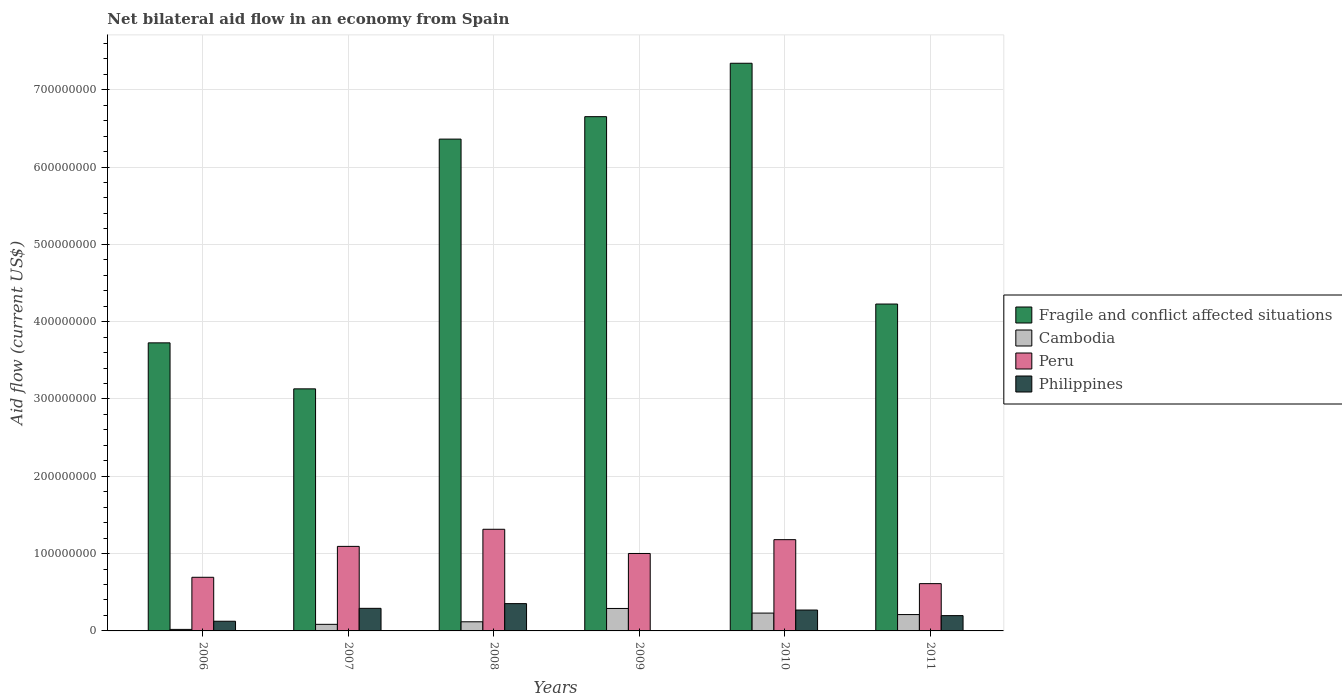Are the number of bars on each tick of the X-axis equal?
Your response must be concise. No. In how many cases, is the number of bars for a given year not equal to the number of legend labels?
Your response must be concise. 1. What is the net bilateral aid flow in Fragile and conflict affected situations in 2006?
Your answer should be compact. 3.73e+08. Across all years, what is the maximum net bilateral aid flow in Peru?
Offer a terse response. 1.31e+08. Across all years, what is the minimum net bilateral aid flow in Fragile and conflict affected situations?
Keep it short and to the point. 3.13e+08. What is the total net bilateral aid flow in Cambodia in the graph?
Give a very brief answer. 9.56e+07. What is the difference between the net bilateral aid flow in Cambodia in 2007 and that in 2009?
Provide a short and direct response. -2.05e+07. What is the average net bilateral aid flow in Fragile and conflict affected situations per year?
Your answer should be compact. 5.24e+08. In the year 2008, what is the difference between the net bilateral aid flow in Peru and net bilateral aid flow in Philippines?
Make the answer very short. 9.62e+07. What is the ratio of the net bilateral aid flow in Cambodia in 2006 to that in 2009?
Provide a short and direct response. 0.07. What is the difference between the highest and the second highest net bilateral aid flow in Peru?
Give a very brief answer. 1.34e+07. What is the difference between the highest and the lowest net bilateral aid flow in Philippines?
Keep it short and to the point. 3.53e+07. In how many years, is the net bilateral aid flow in Philippines greater than the average net bilateral aid flow in Philippines taken over all years?
Offer a very short reply. 3. Is the sum of the net bilateral aid flow in Peru in 2010 and 2011 greater than the maximum net bilateral aid flow in Cambodia across all years?
Give a very brief answer. Yes. How many bars are there?
Provide a succinct answer. 23. Are all the bars in the graph horizontal?
Your answer should be very brief. No. How many years are there in the graph?
Provide a short and direct response. 6. Does the graph contain any zero values?
Keep it short and to the point. Yes. How many legend labels are there?
Your response must be concise. 4. How are the legend labels stacked?
Offer a terse response. Vertical. What is the title of the graph?
Ensure brevity in your answer.  Net bilateral aid flow in an economy from Spain. Does "Papua New Guinea" appear as one of the legend labels in the graph?
Ensure brevity in your answer.  No. What is the label or title of the Y-axis?
Keep it short and to the point. Aid flow (current US$). What is the Aid flow (current US$) of Fragile and conflict affected situations in 2006?
Offer a terse response. 3.73e+08. What is the Aid flow (current US$) of Cambodia in 2006?
Offer a terse response. 1.97e+06. What is the Aid flow (current US$) in Peru in 2006?
Offer a terse response. 6.94e+07. What is the Aid flow (current US$) of Philippines in 2006?
Provide a succinct answer. 1.25e+07. What is the Aid flow (current US$) in Fragile and conflict affected situations in 2007?
Your answer should be compact. 3.13e+08. What is the Aid flow (current US$) of Cambodia in 2007?
Your answer should be compact. 8.52e+06. What is the Aid flow (current US$) of Peru in 2007?
Offer a terse response. 1.09e+08. What is the Aid flow (current US$) of Philippines in 2007?
Provide a succinct answer. 2.92e+07. What is the Aid flow (current US$) of Fragile and conflict affected situations in 2008?
Your answer should be compact. 6.36e+08. What is the Aid flow (current US$) of Cambodia in 2008?
Offer a very short reply. 1.18e+07. What is the Aid flow (current US$) of Peru in 2008?
Provide a short and direct response. 1.31e+08. What is the Aid flow (current US$) in Philippines in 2008?
Give a very brief answer. 3.53e+07. What is the Aid flow (current US$) of Fragile and conflict affected situations in 2009?
Your answer should be compact. 6.65e+08. What is the Aid flow (current US$) in Cambodia in 2009?
Give a very brief answer. 2.90e+07. What is the Aid flow (current US$) in Peru in 2009?
Your answer should be compact. 1.00e+08. What is the Aid flow (current US$) of Philippines in 2009?
Provide a short and direct response. 0. What is the Aid flow (current US$) in Fragile and conflict affected situations in 2010?
Your response must be concise. 7.34e+08. What is the Aid flow (current US$) in Cambodia in 2010?
Provide a succinct answer. 2.31e+07. What is the Aid flow (current US$) of Peru in 2010?
Your response must be concise. 1.18e+08. What is the Aid flow (current US$) in Philippines in 2010?
Ensure brevity in your answer.  2.70e+07. What is the Aid flow (current US$) in Fragile and conflict affected situations in 2011?
Your answer should be compact. 4.23e+08. What is the Aid flow (current US$) of Cambodia in 2011?
Your answer should be compact. 2.12e+07. What is the Aid flow (current US$) of Peru in 2011?
Provide a short and direct response. 6.12e+07. What is the Aid flow (current US$) in Philippines in 2011?
Provide a short and direct response. 1.98e+07. Across all years, what is the maximum Aid flow (current US$) of Fragile and conflict affected situations?
Offer a terse response. 7.34e+08. Across all years, what is the maximum Aid flow (current US$) in Cambodia?
Provide a succinct answer. 2.90e+07. Across all years, what is the maximum Aid flow (current US$) in Peru?
Your answer should be compact. 1.31e+08. Across all years, what is the maximum Aid flow (current US$) in Philippines?
Your answer should be very brief. 3.53e+07. Across all years, what is the minimum Aid flow (current US$) of Fragile and conflict affected situations?
Your answer should be compact. 3.13e+08. Across all years, what is the minimum Aid flow (current US$) of Cambodia?
Your answer should be compact. 1.97e+06. Across all years, what is the minimum Aid flow (current US$) of Peru?
Keep it short and to the point. 6.12e+07. Across all years, what is the minimum Aid flow (current US$) in Philippines?
Provide a succinct answer. 0. What is the total Aid flow (current US$) of Fragile and conflict affected situations in the graph?
Provide a succinct answer. 3.14e+09. What is the total Aid flow (current US$) of Cambodia in the graph?
Your response must be concise. 9.56e+07. What is the total Aid flow (current US$) of Peru in the graph?
Your answer should be very brief. 5.90e+08. What is the total Aid flow (current US$) in Philippines in the graph?
Provide a succinct answer. 1.24e+08. What is the difference between the Aid flow (current US$) in Fragile and conflict affected situations in 2006 and that in 2007?
Give a very brief answer. 5.95e+07. What is the difference between the Aid flow (current US$) in Cambodia in 2006 and that in 2007?
Provide a short and direct response. -6.55e+06. What is the difference between the Aid flow (current US$) of Peru in 2006 and that in 2007?
Offer a terse response. -4.00e+07. What is the difference between the Aid flow (current US$) in Philippines in 2006 and that in 2007?
Ensure brevity in your answer.  -1.67e+07. What is the difference between the Aid flow (current US$) in Fragile and conflict affected situations in 2006 and that in 2008?
Give a very brief answer. -2.64e+08. What is the difference between the Aid flow (current US$) of Cambodia in 2006 and that in 2008?
Your answer should be compact. -9.84e+06. What is the difference between the Aid flow (current US$) in Peru in 2006 and that in 2008?
Ensure brevity in your answer.  -6.21e+07. What is the difference between the Aid flow (current US$) of Philippines in 2006 and that in 2008?
Provide a short and direct response. -2.28e+07. What is the difference between the Aid flow (current US$) of Fragile and conflict affected situations in 2006 and that in 2009?
Offer a very short reply. -2.93e+08. What is the difference between the Aid flow (current US$) of Cambodia in 2006 and that in 2009?
Make the answer very short. -2.71e+07. What is the difference between the Aid flow (current US$) in Peru in 2006 and that in 2009?
Provide a short and direct response. -3.08e+07. What is the difference between the Aid flow (current US$) in Fragile and conflict affected situations in 2006 and that in 2010?
Your response must be concise. -3.62e+08. What is the difference between the Aid flow (current US$) of Cambodia in 2006 and that in 2010?
Offer a very short reply. -2.11e+07. What is the difference between the Aid flow (current US$) in Peru in 2006 and that in 2010?
Offer a terse response. -4.87e+07. What is the difference between the Aid flow (current US$) in Philippines in 2006 and that in 2010?
Your answer should be compact. -1.45e+07. What is the difference between the Aid flow (current US$) of Fragile and conflict affected situations in 2006 and that in 2011?
Offer a terse response. -5.02e+07. What is the difference between the Aid flow (current US$) of Cambodia in 2006 and that in 2011?
Your response must be concise. -1.92e+07. What is the difference between the Aid flow (current US$) of Peru in 2006 and that in 2011?
Keep it short and to the point. 8.21e+06. What is the difference between the Aid flow (current US$) in Philippines in 2006 and that in 2011?
Your response must be concise. -7.28e+06. What is the difference between the Aid flow (current US$) of Fragile and conflict affected situations in 2007 and that in 2008?
Keep it short and to the point. -3.23e+08. What is the difference between the Aid flow (current US$) in Cambodia in 2007 and that in 2008?
Offer a terse response. -3.29e+06. What is the difference between the Aid flow (current US$) in Peru in 2007 and that in 2008?
Provide a succinct answer. -2.21e+07. What is the difference between the Aid flow (current US$) of Philippines in 2007 and that in 2008?
Offer a terse response. -6.10e+06. What is the difference between the Aid flow (current US$) of Fragile and conflict affected situations in 2007 and that in 2009?
Make the answer very short. -3.52e+08. What is the difference between the Aid flow (current US$) in Cambodia in 2007 and that in 2009?
Your answer should be compact. -2.05e+07. What is the difference between the Aid flow (current US$) of Peru in 2007 and that in 2009?
Make the answer very short. 9.18e+06. What is the difference between the Aid flow (current US$) of Fragile and conflict affected situations in 2007 and that in 2010?
Your answer should be compact. -4.21e+08. What is the difference between the Aid flow (current US$) in Cambodia in 2007 and that in 2010?
Provide a short and direct response. -1.46e+07. What is the difference between the Aid flow (current US$) in Peru in 2007 and that in 2010?
Make the answer very short. -8.70e+06. What is the difference between the Aid flow (current US$) of Philippines in 2007 and that in 2010?
Offer a terse response. 2.20e+06. What is the difference between the Aid flow (current US$) in Fragile and conflict affected situations in 2007 and that in 2011?
Make the answer very short. -1.10e+08. What is the difference between the Aid flow (current US$) of Cambodia in 2007 and that in 2011?
Your answer should be compact. -1.26e+07. What is the difference between the Aid flow (current US$) of Peru in 2007 and that in 2011?
Your response must be concise. 4.82e+07. What is the difference between the Aid flow (current US$) in Philippines in 2007 and that in 2011?
Make the answer very short. 9.41e+06. What is the difference between the Aid flow (current US$) in Fragile and conflict affected situations in 2008 and that in 2009?
Keep it short and to the point. -2.90e+07. What is the difference between the Aid flow (current US$) in Cambodia in 2008 and that in 2009?
Make the answer very short. -1.72e+07. What is the difference between the Aid flow (current US$) of Peru in 2008 and that in 2009?
Offer a terse response. 3.13e+07. What is the difference between the Aid flow (current US$) in Fragile and conflict affected situations in 2008 and that in 2010?
Give a very brief answer. -9.81e+07. What is the difference between the Aid flow (current US$) in Cambodia in 2008 and that in 2010?
Your answer should be compact. -1.13e+07. What is the difference between the Aid flow (current US$) of Peru in 2008 and that in 2010?
Ensure brevity in your answer.  1.34e+07. What is the difference between the Aid flow (current US$) of Philippines in 2008 and that in 2010?
Provide a succinct answer. 8.30e+06. What is the difference between the Aid flow (current US$) of Fragile and conflict affected situations in 2008 and that in 2011?
Offer a very short reply. 2.13e+08. What is the difference between the Aid flow (current US$) in Cambodia in 2008 and that in 2011?
Provide a short and direct response. -9.34e+06. What is the difference between the Aid flow (current US$) in Peru in 2008 and that in 2011?
Provide a short and direct response. 7.03e+07. What is the difference between the Aid flow (current US$) in Philippines in 2008 and that in 2011?
Your answer should be compact. 1.55e+07. What is the difference between the Aid flow (current US$) of Fragile and conflict affected situations in 2009 and that in 2010?
Provide a short and direct response. -6.91e+07. What is the difference between the Aid flow (current US$) in Cambodia in 2009 and that in 2010?
Your response must be concise. 5.97e+06. What is the difference between the Aid flow (current US$) in Peru in 2009 and that in 2010?
Offer a terse response. -1.79e+07. What is the difference between the Aid flow (current US$) in Fragile and conflict affected situations in 2009 and that in 2011?
Give a very brief answer. 2.42e+08. What is the difference between the Aid flow (current US$) in Cambodia in 2009 and that in 2011?
Give a very brief answer. 7.90e+06. What is the difference between the Aid flow (current US$) of Peru in 2009 and that in 2011?
Your response must be concise. 3.90e+07. What is the difference between the Aid flow (current US$) of Fragile and conflict affected situations in 2010 and that in 2011?
Ensure brevity in your answer.  3.11e+08. What is the difference between the Aid flow (current US$) of Cambodia in 2010 and that in 2011?
Give a very brief answer. 1.93e+06. What is the difference between the Aid flow (current US$) of Peru in 2010 and that in 2011?
Give a very brief answer. 5.69e+07. What is the difference between the Aid flow (current US$) in Philippines in 2010 and that in 2011?
Your answer should be compact. 7.21e+06. What is the difference between the Aid flow (current US$) in Fragile and conflict affected situations in 2006 and the Aid flow (current US$) in Cambodia in 2007?
Your answer should be compact. 3.64e+08. What is the difference between the Aid flow (current US$) in Fragile and conflict affected situations in 2006 and the Aid flow (current US$) in Peru in 2007?
Your answer should be compact. 2.63e+08. What is the difference between the Aid flow (current US$) in Fragile and conflict affected situations in 2006 and the Aid flow (current US$) in Philippines in 2007?
Your answer should be very brief. 3.43e+08. What is the difference between the Aid flow (current US$) of Cambodia in 2006 and the Aid flow (current US$) of Peru in 2007?
Offer a very short reply. -1.07e+08. What is the difference between the Aid flow (current US$) in Cambodia in 2006 and the Aid flow (current US$) in Philippines in 2007?
Ensure brevity in your answer.  -2.72e+07. What is the difference between the Aid flow (current US$) of Peru in 2006 and the Aid flow (current US$) of Philippines in 2007?
Provide a succinct answer. 4.02e+07. What is the difference between the Aid flow (current US$) in Fragile and conflict affected situations in 2006 and the Aid flow (current US$) in Cambodia in 2008?
Make the answer very short. 3.61e+08. What is the difference between the Aid flow (current US$) in Fragile and conflict affected situations in 2006 and the Aid flow (current US$) in Peru in 2008?
Your answer should be very brief. 2.41e+08. What is the difference between the Aid flow (current US$) of Fragile and conflict affected situations in 2006 and the Aid flow (current US$) of Philippines in 2008?
Ensure brevity in your answer.  3.37e+08. What is the difference between the Aid flow (current US$) in Cambodia in 2006 and the Aid flow (current US$) in Peru in 2008?
Your response must be concise. -1.30e+08. What is the difference between the Aid flow (current US$) in Cambodia in 2006 and the Aid flow (current US$) in Philippines in 2008?
Keep it short and to the point. -3.33e+07. What is the difference between the Aid flow (current US$) of Peru in 2006 and the Aid flow (current US$) of Philippines in 2008?
Ensure brevity in your answer.  3.41e+07. What is the difference between the Aid flow (current US$) in Fragile and conflict affected situations in 2006 and the Aid flow (current US$) in Cambodia in 2009?
Your response must be concise. 3.44e+08. What is the difference between the Aid flow (current US$) of Fragile and conflict affected situations in 2006 and the Aid flow (current US$) of Peru in 2009?
Make the answer very short. 2.72e+08. What is the difference between the Aid flow (current US$) in Cambodia in 2006 and the Aid flow (current US$) in Peru in 2009?
Your answer should be very brief. -9.82e+07. What is the difference between the Aid flow (current US$) in Fragile and conflict affected situations in 2006 and the Aid flow (current US$) in Cambodia in 2010?
Ensure brevity in your answer.  3.50e+08. What is the difference between the Aid flow (current US$) in Fragile and conflict affected situations in 2006 and the Aid flow (current US$) in Peru in 2010?
Ensure brevity in your answer.  2.55e+08. What is the difference between the Aid flow (current US$) of Fragile and conflict affected situations in 2006 and the Aid flow (current US$) of Philippines in 2010?
Your response must be concise. 3.46e+08. What is the difference between the Aid flow (current US$) in Cambodia in 2006 and the Aid flow (current US$) in Peru in 2010?
Ensure brevity in your answer.  -1.16e+08. What is the difference between the Aid flow (current US$) in Cambodia in 2006 and the Aid flow (current US$) in Philippines in 2010?
Provide a succinct answer. -2.50e+07. What is the difference between the Aid flow (current US$) of Peru in 2006 and the Aid flow (current US$) of Philippines in 2010?
Provide a succinct answer. 4.24e+07. What is the difference between the Aid flow (current US$) of Fragile and conflict affected situations in 2006 and the Aid flow (current US$) of Cambodia in 2011?
Give a very brief answer. 3.51e+08. What is the difference between the Aid flow (current US$) of Fragile and conflict affected situations in 2006 and the Aid flow (current US$) of Peru in 2011?
Ensure brevity in your answer.  3.11e+08. What is the difference between the Aid flow (current US$) of Fragile and conflict affected situations in 2006 and the Aid flow (current US$) of Philippines in 2011?
Provide a short and direct response. 3.53e+08. What is the difference between the Aid flow (current US$) of Cambodia in 2006 and the Aid flow (current US$) of Peru in 2011?
Provide a short and direct response. -5.92e+07. What is the difference between the Aid flow (current US$) of Cambodia in 2006 and the Aid flow (current US$) of Philippines in 2011?
Provide a succinct answer. -1.78e+07. What is the difference between the Aid flow (current US$) of Peru in 2006 and the Aid flow (current US$) of Philippines in 2011?
Ensure brevity in your answer.  4.96e+07. What is the difference between the Aid flow (current US$) of Fragile and conflict affected situations in 2007 and the Aid flow (current US$) of Cambodia in 2008?
Make the answer very short. 3.01e+08. What is the difference between the Aid flow (current US$) in Fragile and conflict affected situations in 2007 and the Aid flow (current US$) in Peru in 2008?
Provide a short and direct response. 1.82e+08. What is the difference between the Aid flow (current US$) in Fragile and conflict affected situations in 2007 and the Aid flow (current US$) in Philippines in 2008?
Your response must be concise. 2.78e+08. What is the difference between the Aid flow (current US$) in Cambodia in 2007 and the Aid flow (current US$) in Peru in 2008?
Provide a succinct answer. -1.23e+08. What is the difference between the Aid flow (current US$) in Cambodia in 2007 and the Aid flow (current US$) in Philippines in 2008?
Provide a succinct answer. -2.68e+07. What is the difference between the Aid flow (current US$) of Peru in 2007 and the Aid flow (current US$) of Philippines in 2008?
Make the answer very short. 7.40e+07. What is the difference between the Aid flow (current US$) of Fragile and conflict affected situations in 2007 and the Aid flow (current US$) of Cambodia in 2009?
Keep it short and to the point. 2.84e+08. What is the difference between the Aid flow (current US$) of Fragile and conflict affected situations in 2007 and the Aid flow (current US$) of Peru in 2009?
Your answer should be very brief. 2.13e+08. What is the difference between the Aid flow (current US$) of Cambodia in 2007 and the Aid flow (current US$) of Peru in 2009?
Offer a very short reply. -9.16e+07. What is the difference between the Aid flow (current US$) of Fragile and conflict affected situations in 2007 and the Aid flow (current US$) of Cambodia in 2010?
Ensure brevity in your answer.  2.90e+08. What is the difference between the Aid flow (current US$) of Fragile and conflict affected situations in 2007 and the Aid flow (current US$) of Peru in 2010?
Offer a very short reply. 1.95e+08. What is the difference between the Aid flow (current US$) in Fragile and conflict affected situations in 2007 and the Aid flow (current US$) in Philippines in 2010?
Make the answer very short. 2.86e+08. What is the difference between the Aid flow (current US$) of Cambodia in 2007 and the Aid flow (current US$) of Peru in 2010?
Provide a succinct answer. -1.10e+08. What is the difference between the Aid flow (current US$) of Cambodia in 2007 and the Aid flow (current US$) of Philippines in 2010?
Give a very brief answer. -1.85e+07. What is the difference between the Aid flow (current US$) in Peru in 2007 and the Aid flow (current US$) in Philippines in 2010?
Your answer should be compact. 8.23e+07. What is the difference between the Aid flow (current US$) in Fragile and conflict affected situations in 2007 and the Aid flow (current US$) in Cambodia in 2011?
Keep it short and to the point. 2.92e+08. What is the difference between the Aid flow (current US$) of Fragile and conflict affected situations in 2007 and the Aid flow (current US$) of Peru in 2011?
Provide a succinct answer. 2.52e+08. What is the difference between the Aid flow (current US$) in Fragile and conflict affected situations in 2007 and the Aid flow (current US$) in Philippines in 2011?
Make the answer very short. 2.93e+08. What is the difference between the Aid flow (current US$) in Cambodia in 2007 and the Aid flow (current US$) in Peru in 2011?
Give a very brief answer. -5.26e+07. What is the difference between the Aid flow (current US$) in Cambodia in 2007 and the Aid flow (current US$) in Philippines in 2011?
Your response must be concise. -1.13e+07. What is the difference between the Aid flow (current US$) of Peru in 2007 and the Aid flow (current US$) of Philippines in 2011?
Make the answer very short. 8.96e+07. What is the difference between the Aid flow (current US$) of Fragile and conflict affected situations in 2008 and the Aid flow (current US$) of Cambodia in 2009?
Provide a succinct answer. 6.07e+08. What is the difference between the Aid flow (current US$) in Fragile and conflict affected situations in 2008 and the Aid flow (current US$) in Peru in 2009?
Provide a succinct answer. 5.36e+08. What is the difference between the Aid flow (current US$) in Cambodia in 2008 and the Aid flow (current US$) in Peru in 2009?
Your answer should be compact. -8.84e+07. What is the difference between the Aid flow (current US$) in Fragile and conflict affected situations in 2008 and the Aid flow (current US$) in Cambodia in 2010?
Your response must be concise. 6.13e+08. What is the difference between the Aid flow (current US$) of Fragile and conflict affected situations in 2008 and the Aid flow (current US$) of Peru in 2010?
Make the answer very short. 5.18e+08. What is the difference between the Aid flow (current US$) in Fragile and conflict affected situations in 2008 and the Aid flow (current US$) in Philippines in 2010?
Offer a very short reply. 6.09e+08. What is the difference between the Aid flow (current US$) in Cambodia in 2008 and the Aid flow (current US$) in Peru in 2010?
Your answer should be very brief. -1.06e+08. What is the difference between the Aid flow (current US$) in Cambodia in 2008 and the Aid flow (current US$) in Philippines in 2010?
Keep it short and to the point. -1.52e+07. What is the difference between the Aid flow (current US$) in Peru in 2008 and the Aid flow (current US$) in Philippines in 2010?
Give a very brief answer. 1.04e+08. What is the difference between the Aid flow (current US$) of Fragile and conflict affected situations in 2008 and the Aid flow (current US$) of Cambodia in 2011?
Offer a terse response. 6.15e+08. What is the difference between the Aid flow (current US$) of Fragile and conflict affected situations in 2008 and the Aid flow (current US$) of Peru in 2011?
Provide a succinct answer. 5.75e+08. What is the difference between the Aid flow (current US$) in Fragile and conflict affected situations in 2008 and the Aid flow (current US$) in Philippines in 2011?
Provide a succinct answer. 6.16e+08. What is the difference between the Aid flow (current US$) of Cambodia in 2008 and the Aid flow (current US$) of Peru in 2011?
Make the answer very short. -4.94e+07. What is the difference between the Aid flow (current US$) in Cambodia in 2008 and the Aid flow (current US$) in Philippines in 2011?
Provide a succinct answer. -7.99e+06. What is the difference between the Aid flow (current US$) of Peru in 2008 and the Aid flow (current US$) of Philippines in 2011?
Give a very brief answer. 1.12e+08. What is the difference between the Aid flow (current US$) of Fragile and conflict affected situations in 2009 and the Aid flow (current US$) of Cambodia in 2010?
Offer a terse response. 6.42e+08. What is the difference between the Aid flow (current US$) of Fragile and conflict affected situations in 2009 and the Aid flow (current US$) of Peru in 2010?
Make the answer very short. 5.47e+08. What is the difference between the Aid flow (current US$) of Fragile and conflict affected situations in 2009 and the Aid flow (current US$) of Philippines in 2010?
Your response must be concise. 6.38e+08. What is the difference between the Aid flow (current US$) of Cambodia in 2009 and the Aid flow (current US$) of Peru in 2010?
Provide a short and direct response. -8.90e+07. What is the difference between the Aid flow (current US$) of Cambodia in 2009 and the Aid flow (current US$) of Philippines in 2010?
Give a very brief answer. 2.04e+06. What is the difference between the Aid flow (current US$) in Peru in 2009 and the Aid flow (current US$) in Philippines in 2010?
Make the answer very short. 7.32e+07. What is the difference between the Aid flow (current US$) in Fragile and conflict affected situations in 2009 and the Aid flow (current US$) in Cambodia in 2011?
Make the answer very short. 6.44e+08. What is the difference between the Aid flow (current US$) of Fragile and conflict affected situations in 2009 and the Aid flow (current US$) of Peru in 2011?
Offer a very short reply. 6.04e+08. What is the difference between the Aid flow (current US$) in Fragile and conflict affected situations in 2009 and the Aid flow (current US$) in Philippines in 2011?
Offer a very short reply. 6.45e+08. What is the difference between the Aid flow (current US$) of Cambodia in 2009 and the Aid flow (current US$) of Peru in 2011?
Provide a succinct answer. -3.21e+07. What is the difference between the Aid flow (current US$) in Cambodia in 2009 and the Aid flow (current US$) in Philippines in 2011?
Provide a succinct answer. 9.25e+06. What is the difference between the Aid flow (current US$) in Peru in 2009 and the Aid flow (current US$) in Philippines in 2011?
Offer a terse response. 8.04e+07. What is the difference between the Aid flow (current US$) of Fragile and conflict affected situations in 2010 and the Aid flow (current US$) of Cambodia in 2011?
Ensure brevity in your answer.  7.13e+08. What is the difference between the Aid flow (current US$) of Fragile and conflict affected situations in 2010 and the Aid flow (current US$) of Peru in 2011?
Provide a short and direct response. 6.73e+08. What is the difference between the Aid flow (current US$) of Fragile and conflict affected situations in 2010 and the Aid flow (current US$) of Philippines in 2011?
Your answer should be very brief. 7.14e+08. What is the difference between the Aid flow (current US$) in Cambodia in 2010 and the Aid flow (current US$) in Peru in 2011?
Ensure brevity in your answer.  -3.81e+07. What is the difference between the Aid flow (current US$) in Cambodia in 2010 and the Aid flow (current US$) in Philippines in 2011?
Provide a short and direct response. 3.28e+06. What is the difference between the Aid flow (current US$) of Peru in 2010 and the Aid flow (current US$) of Philippines in 2011?
Keep it short and to the point. 9.82e+07. What is the average Aid flow (current US$) in Fragile and conflict affected situations per year?
Give a very brief answer. 5.24e+08. What is the average Aid flow (current US$) in Cambodia per year?
Your response must be concise. 1.59e+07. What is the average Aid flow (current US$) of Peru per year?
Offer a very short reply. 9.83e+07. What is the average Aid flow (current US$) of Philippines per year?
Your answer should be very brief. 2.06e+07. In the year 2006, what is the difference between the Aid flow (current US$) of Fragile and conflict affected situations and Aid flow (current US$) of Cambodia?
Ensure brevity in your answer.  3.71e+08. In the year 2006, what is the difference between the Aid flow (current US$) in Fragile and conflict affected situations and Aid flow (current US$) in Peru?
Offer a terse response. 3.03e+08. In the year 2006, what is the difference between the Aid flow (current US$) of Fragile and conflict affected situations and Aid flow (current US$) of Philippines?
Make the answer very short. 3.60e+08. In the year 2006, what is the difference between the Aid flow (current US$) in Cambodia and Aid flow (current US$) in Peru?
Ensure brevity in your answer.  -6.74e+07. In the year 2006, what is the difference between the Aid flow (current US$) of Cambodia and Aid flow (current US$) of Philippines?
Offer a very short reply. -1.06e+07. In the year 2006, what is the difference between the Aid flow (current US$) of Peru and Aid flow (current US$) of Philippines?
Ensure brevity in your answer.  5.68e+07. In the year 2007, what is the difference between the Aid flow (current US$) in Fragile and conflict affected situations and Aid flow (current US$) in Cambodia?
Keep it short and to the point. 3.05e+08. In the year 2007, what is the difference between the Aid flow (current US$) in Fragile and conflict affected situations and Aid flow (current US$) in Peru?
Keep it short and to the point. 2.04e+08. In the year 2007, what is the difference between the Aid flow (current US$) of Fragile and conflict affected situations and Aid flow (current US$) of Philippines?
Your response must be concise. 2.84e+08. In the year 2007, what is the difference between the Aid flow (current US$) of Cambodia and Aid flow (current US$) of Peru?
Keep it short and to the point. -1.01e+08. In the year 2007, what is the difference between the Aid flow (current US$) in Cambodia and Aid flow (current US$) in Philippines?
Keep it short and to the point. -2.07e+07. In the year 2007, what is the difference between the Aid flow (current US$) of Peru and Aid flow (current US$) of Philippines?
Give a very brief answer. 8.01e+07. In the year 2008, what is the difference between the Aid flow (current US$) of Fragile and conflict affected situations and Aid flow (current US$) of Cambodia?
Offer a very short reply. 6.24e+08. In the year 2008, what is the difference between the Aid flow (current US$) of Fragile and conflict affected situations and Aid flow (current US$) of Peru?
Provide a succinct answer. 5.05e+08. In the year 2008, what is the difference between the Aid flow (current US$) of Fragile and conflict affected situations and Aid flow (current US$) of Philippines?
Offer a terse response. 6.01e+08. In the year 2008, what is the difference between the Aid flow (current US$) in Cambodia and Aid flow (current US$) in Peru?
Provide a succinct answer. -1.20e+08. In the year 2008, what is the difference between the Aid flow (current US$) of Cambodia and Aid flow (current US$) of Philippines?
Provide a short and direct response. -2.35e+07. In the year 2008, what is the difference between the Aid flow (current US$) of Peru and Aid flow (current US$) of Philippines?
Your answer should be very brief. 9.62e+07. In the year 2009, what is the difference between the Aid flow (current US$) of Fragile and conflict affected situations and Aid flow (current US$) of Cambodia?
Make the answer very short. 6.36e+08. In the year 2009, what is the difference between the Aid flow (current US$) in Fragile and conflict affected situations and Aid flow (current US$) in Peru?
Make the answer very short. 5.65e+08. In the year 2009, what is the difference between the Aid flow (current US$) of Cambodia and Aid flow (current US$) of Peru?
Your answer should be compact. -7.11e+07. In the year 2010, what is the difference between the Aid flow (current US$) of Fragile and conflict affected situations and Aid flow (current US$) of Cambodia?
Ensure brevity in your answer.  7.11e+08. In the year 2010, what is the difference between the Aid flow (current US$) in Fragile and conflict affected situations and Aid flow (current US$) in Peru?
Ensure brevity in your answer.  6.16e+08. In the year 2010, what is the difference between the Aid flow (current US$) in Fragile and conflict affected situations and Aid flow (current US$) in Philippines?
Provide a succinct answer. 7.07e+08. In the year 2010, what is the difference between the Aid flow (current US$) in Cambodia and Aid flow (current US$) in Peru?
Your answer should be compact. -9.50e+07. In the year 2010, what is the difference between the Aid flow (current US$) of Cambodia and Aid flow (current US$) of Philippines?
Your response must be concise. -3.93e+06. In the year 2010, what is the difference between the Aid flow (current US$) of Peru and Aid flow (current US$) of Philippines?
Provide a short and direct response. 9.10e+07. In the year 2011, what is the difference between the Aid flow (current US$) in Fragile and conflict affected situations and Aid flow (current US$) in Cambodia?
Make the answer very short. 4.02e+08. In the year 2011, what is the difference between the Aid flow (current US$) of Fragile and conflict affected situations and Aid flow (current US$) of Peru?
Provide a succinct answer. 3.62e+08. In the year 2011, what is the difference between the Aid flow (current US$) in Fragile and conflict affected situations and Aid flow (current US$) in Philippines?
Give a very brief answer. 4.03e+08. In the year 2011, what is the difference between the Aid flow (current US$) of Cambodia and Aid flow (current US$) of Peru?
Your response must be concise. -4.00e+07. In the year 2011, what is the difference between the Aid flow (current US$) in Cambodia and Aid flow (current US$) in Philippines?
Your response must be concise. 1.35e+06. In the year 2011, what is the difference between the Aid flow (current US$) in Peru and Aid flow (current US$) in Philippines?
Your answer should be very brief. 4.14e+07. What is the ratio of the Aid flow (current US$) in Fragile and conflict affected situations in 2006 to that in 2007?
Offer a terse response. 1.19. What is the ratio of the Aid flow (current US$) in Cambodia in 2006 to that in 2007?
Ensure brevity in your answer.  0.23. What is the ratio of the Aid flow (current US$) in Peru in 2006 to that in 2007?
Give a very brief answer. 0.63. What is the ratio of the Aid flow (current US$) in Philippines in 2006 to that in 2007?
Offer a terse response. 0.43. What is the ratio of the Aid flow (current US$) of Fragile and conflict affected situations in 2006 to that in 2008?
Provide a succinct answer. 0.59. What is the ratio of the Aid flow (current US$) of Cambodia in 2006 to that in 2008?
Your answer should be compact. 0.17. What is the ratio of the Aid flow (current US$) in Peru in 2006 to that in 2008?
Provide a succinct answer. 0.53. What is the ratio of the Aid flow (current US$) of Philippines in 2006 to that in 2008?
Offer a terse response. 0.35. What is the ratio of the Aid flow (current US$) in Fragile and conflict affected situations in 2006 to that in 2009?
Your answer should be very brief. 0.56. What is the ratio of the Aid flow (current US$) in Cambodia in 2006 to that in 2009?
Give a very brief answer. 0.07. What is the ratio of the Aid flow (current US$) of Peru in 2006 to that in 2009?
Offer a very short reply. 0.69. What is the ratio of the Aid flow (current US$) of Fragile and conflict affected situations in 2006 to that in 2010?
Give a very brief answer. 0.51. What is the ratio of the Aid flow (current US$) in Cambodia in 2006 to that in 2010?
Keep it short and to the point. 0.09. What is the ratio of the Aid flow (current US$) of Peru in 2006 to that in 2010?
Make the answer very short. 0.59. What is the ratio of the Aid flow (current US$) of Philippines in 2006 to that in 2010?
Keep it short and to the point. 0.46. What is the ratio of the Aid flow (current US$) in Fragile and conflict affected situations in 2006 to that in 2011?
Give a very brief answer. 0.88. What is the ratio of the Aid flow (current US$) of Cambodia in 2006 to that in 2011?
Provide a succinct answer. 0.09. What is the ratio of the Aid flow (current US$) in Peru in 2006 to that in 2011?
Your response must be concise. 1.13. What is the ratio of the Aid flow (current US$) of Philippines in 2006 to that in 2011?
Make the answer very short. 0.63. What is the ratio of the Aid flow (current US$) in Fragile and conflict affected situations in 2007 to that in 2008?
Your answer should be compact. 0.49. What is the ratio of the Aid flow (current US$) in Cambodia in 2007 to that in 2008?
Your answer should be very brief. 0.72. What is the ratio of the Aid flow (current US$) in Peru in 2007 to that in 2008?
Provide a succinct answer. 0.83. What is the ratio of the Aid flow (current US$) in Philippines in 2007 to that in 2008?
Offer a terse response. 0.83. What is the ratio of the Aid flow (current US$) in Fragile and conflict affected situations in 2007 to that in 2009?
Provide a short and direct response. 0.47. What is the ratio of the Aid flow (current US$) in Cambodia in 2007 to that in 2009?
Provide a succinct answer. 0.29. What is the ratio of the Aid flow (current US$) in Peru in 2007 to that in 2009?
Make the answer very short. 1.09. What is the ratio of the Aid flow (current US$) of Fragile and conflict affected situations in 2007 to that in 2010?
Give a very brief answer. 0.43. What is the ratio of the Aid flow (current US$) in Cambodia in 2007 to that in 2010?
Offer a very short reply. 0.37. What is the ratio of the Aid flow (current US$) in Peru in 2007 to that in 2010?
Offer a terse response. 0.93. What is the ratio of the Aid flow (current US$) of Philippines in 2007 to that in 2010?
Offer a very short reply. 1.08. What is the ratio of the Aid flow (current US$) of Fragile and conflict affected situations in 2007 to that in 2011?
Give a very brief answer. 0.74. What is the ratio of the Aid flow (current US$) in Cambodia in 2007 to that in 2011?
Provide a succinct answer. 0.4. What is the ratio of the Aid flow (current US$) in Peru in 2007 to that in 2011?
Your response must be concise. 1.79. What is the ratio of the Aid flow (current US$) of Philippines in 2007 to that in 2011?
Offer a terse response. 1.48. What is the ratio of the Aid flow (current US$) of Fragile and conflict affected situations in 2008 to that in 2009?
Offer a very short reply. 0.96. What is the ratio of the Aid flow (current US$) of Cambodia in 2008 to that in 2009?
Your answer should be compact. 0.41. What is the ratio of the Aid flow (current US$) in Peru in 2008 to that in 2009?
Your answer should be compact. 1.31. What is the ratio of the Aid flow (current US$) in Fragile and conflict affected situations in 2008 to that in 2010?
Make the answer very short. 0.87. What is the ratio of the Aid flow (current US$) in Cambodia in 2008 to that in 2010?
Give a very brief answer. 0.51. What is the ratio of the Aid flow (current US$) in Peru in 2008 to that in 2010?
Your answer should be very brief. 1.11. What is the ratio of the Aid flow (current US$) of Philippines in 2008 to that in 2010?
Provide a succinct answer. 1.31. What is the ratio of the Aid flow (current US$) in Fragile and conflict affected situations in 2008 to that in 2011?
Make the answer very short. 1.5. What is the ratio of the Aid flow (current US$) in Cambodia in 2008 to that in 2011?
Your answer should be very brief. 0.56. What is the ratio of the Aid flow (current US$) in Peru in 2008 to that in 2011?
Your answer should be very brief. 2.15. What is the ratio of the Aid flow (current US$) in Philippines in 2008 to that in 2011?
Provide a short and direct response. 1.78. What is the ratio of the Aid flow (current US$) in Fragile and conflict affected situations in 2009 to that in 2010?
Provide a succinct answer. 0.91. What is the ratio of the Aid flow (current US$) of Cambodia in 2009 to that in 2010?
Give a very brief answer. 1.26. What is the ratio of the Aid flow (current US$) of Peru in 2009 to that in 2010?
Give a very brief answer. 0.85. What is the ratio of the Aid flow (current US$) in Fragile and conflict affected situations in 2009 to that in 2011?
Make the answer very short. 1.57. What is the ratio of the Aid flow (current US$) of Cambodia in 2009 to that in 2011?
Keep it short and to the point. 1.37. What is the ratio of the Aid flow (current US$) of Peru in 2009 to that in 2011?
Your answer should be very brief. 1.64. What is the ratio of the Aid flow (current US$) in Fragile and conflict affected situations in 2010 to that in 2011?
Your response must be concise. 1.74. What is the ratio of the Aid flow (current US$) in Cambodia in 2010 to that in 2011?
Your answer should be compact. 1.09. What is the ratio of the Aid flow (current US$) in Peru in 2010 to that in 2011?
Provide a succinct answer. 1.93. What is the ratio of the Aid flow (current US$) in Philippines in 2010 to that in 2011?
Provide a short and direct response. 1.36. What is the difference between the highest and the second highest Aid flow (current US$) in Fragile and conflict affected situations?
Your response must be concise. 6.91e+07. What is the difference between the highest and the second highest Aid flow (current US$) in Cambodia?
Offer a very short reply. 5.97e+06. What is the difference between the highest and the second highest Aid flow (current US$) in Peru?
Your answer should be very brief. 1.34e+07. What is the difference between the highest and the second highest Aid flow (current US$) of Philippines?
Ensure brevity in your answer.  6.10e+06. What is the difference between the highest and the lowest Aid flow (current US$) in Fragile and conflict affected situations?
Your answer should be very brief. 4.21e+08. What is the difference between the highest and the lowest Aid flow (current US$) in Cambodia?
Make the answer very short. 2.71e+07. What is the difference between the highest and the lowest Aid flow (current US$) in Peru?
Your answer should be compact. 7.03e+07. What is the difference between the highest and the lowest Aid flow (current US$) of Philippines?
Keep it short and to the point. 3.53e+07. 